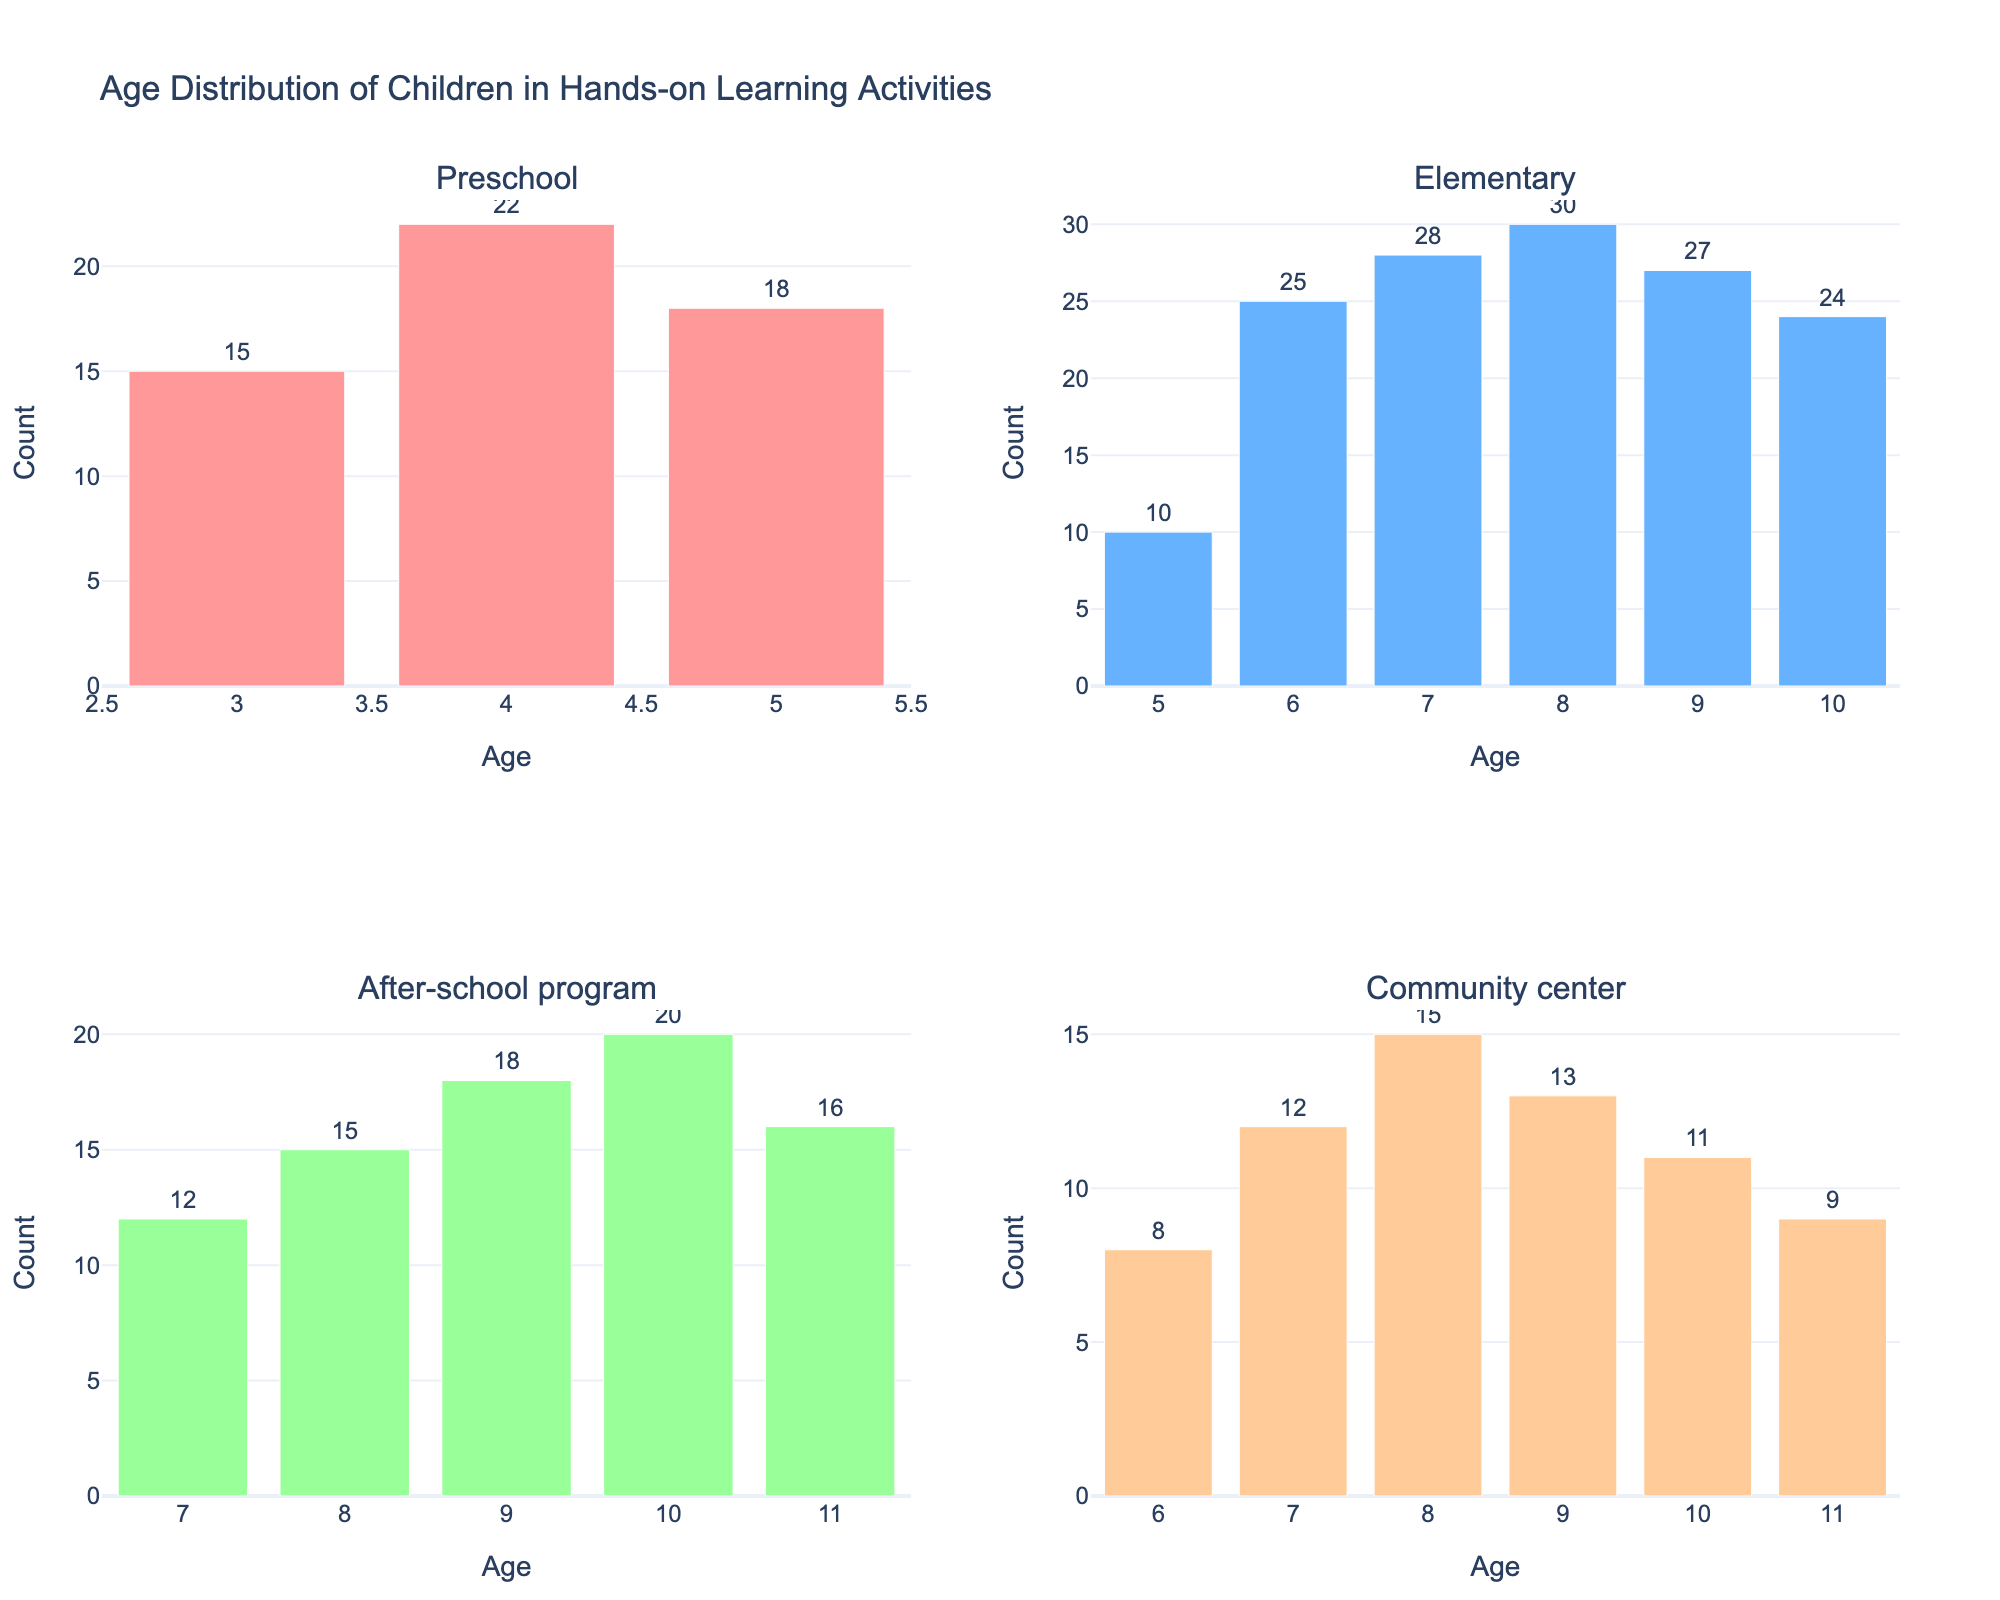What is the title of the figure? The title of the figure is usually positioned at the top of the chart. In this case, it reads "Age Distribution of Children in Hands-on Learning Activities."
Answer: Age Distribution of Children in Hands-on Learning Activities How many subplots are present in the figure? The figure consists of multiple subplots arranged in a 2x2 grid. By counting these, we can see there are 4 subplots.
Answer: 4 What setting has the highest count of 8-year-old children? To find this, look for the largest bar corresponding to age 8 in each subplot. The largest bar for the 8-year-olds is in the Elementary setting with a count of 30.
Answer: Elementary How does the number of 6-year-olds in Elementary compare to that in Community center settings? Locate the bars for 6-year-olds in both subplots. The count is 25 in Elementary and 8 in Community center. By comparing these numbers, we see there are significantly more 6-year-olds in Elementary.
Answer: Elementary has more Which setting has the most diverse age distribution? To determine this, observe the range and variation of counts across ages in each subplot. Elementary shows a wider range (ages 5-10) and higher counts across these ages compared to other settings.
Answer: Elementary What is the total number of children in After-school program settings? Sum the counts for all ages in the After-school program subplot: 12 + 15 + 18 + 20 + 16 = 81.
Answer: 81 What is the average count of children in Preschool settings? Add the counts for Preschool and divide by the number of age groups: (15 + 22 + 18) / 3 = 55 / 3 ≈ 18.33.
Answer: 18.33 In which setting do 10-year-old children participate most? Look for the highest bar corresponding to age 10 across the subplots. The highest count of 10-year-olds is in the After-school program setting with 20.
Answer: After-school program Compare the number of 7-year-old children in Elementary and Community center settings. Which has more? By observing the bars for 7-year-olds, Elementary has 28 while Community center has 12. Therefore, Elementary has more.
Answer: Elementary If you combine the counts of 9-year-old children across all settings, what is the total? Add the counts of 9-year-olds from each setting: 27 (Elementary) + 18 (After-school program) + 13 (Community center) = 58.
Answer: 58 